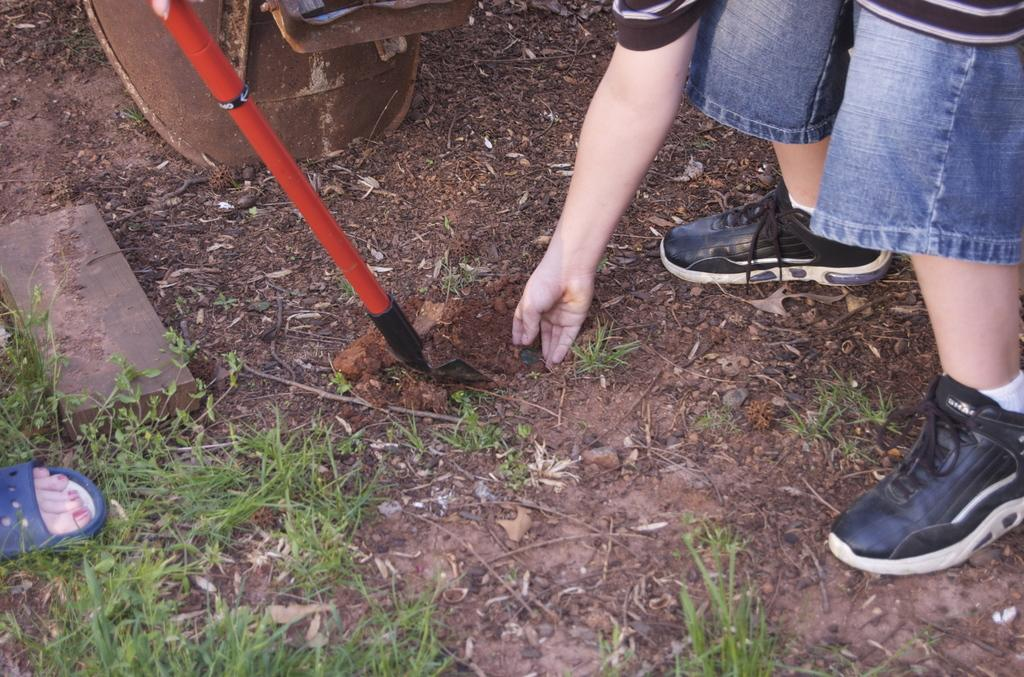What part of a person's body is visible in the image? There is a person's hand in the image. What type of footwear is the person wearing? The person is wearing black shoes. What object can be seen in the image that is typically used for digging? There is a spade in the image. What type of surface is visible on the ground in the image? There is grass on the ground in the image. What type of truck can be seen driving through the grass in the image? There is no truck present in the image; it only features a person's hand, black shoes, a spade, and grass on the ground. 